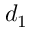<formula> <loc_0><loc_0><loc_500><loc_500>d _ { 1 }</formula> 